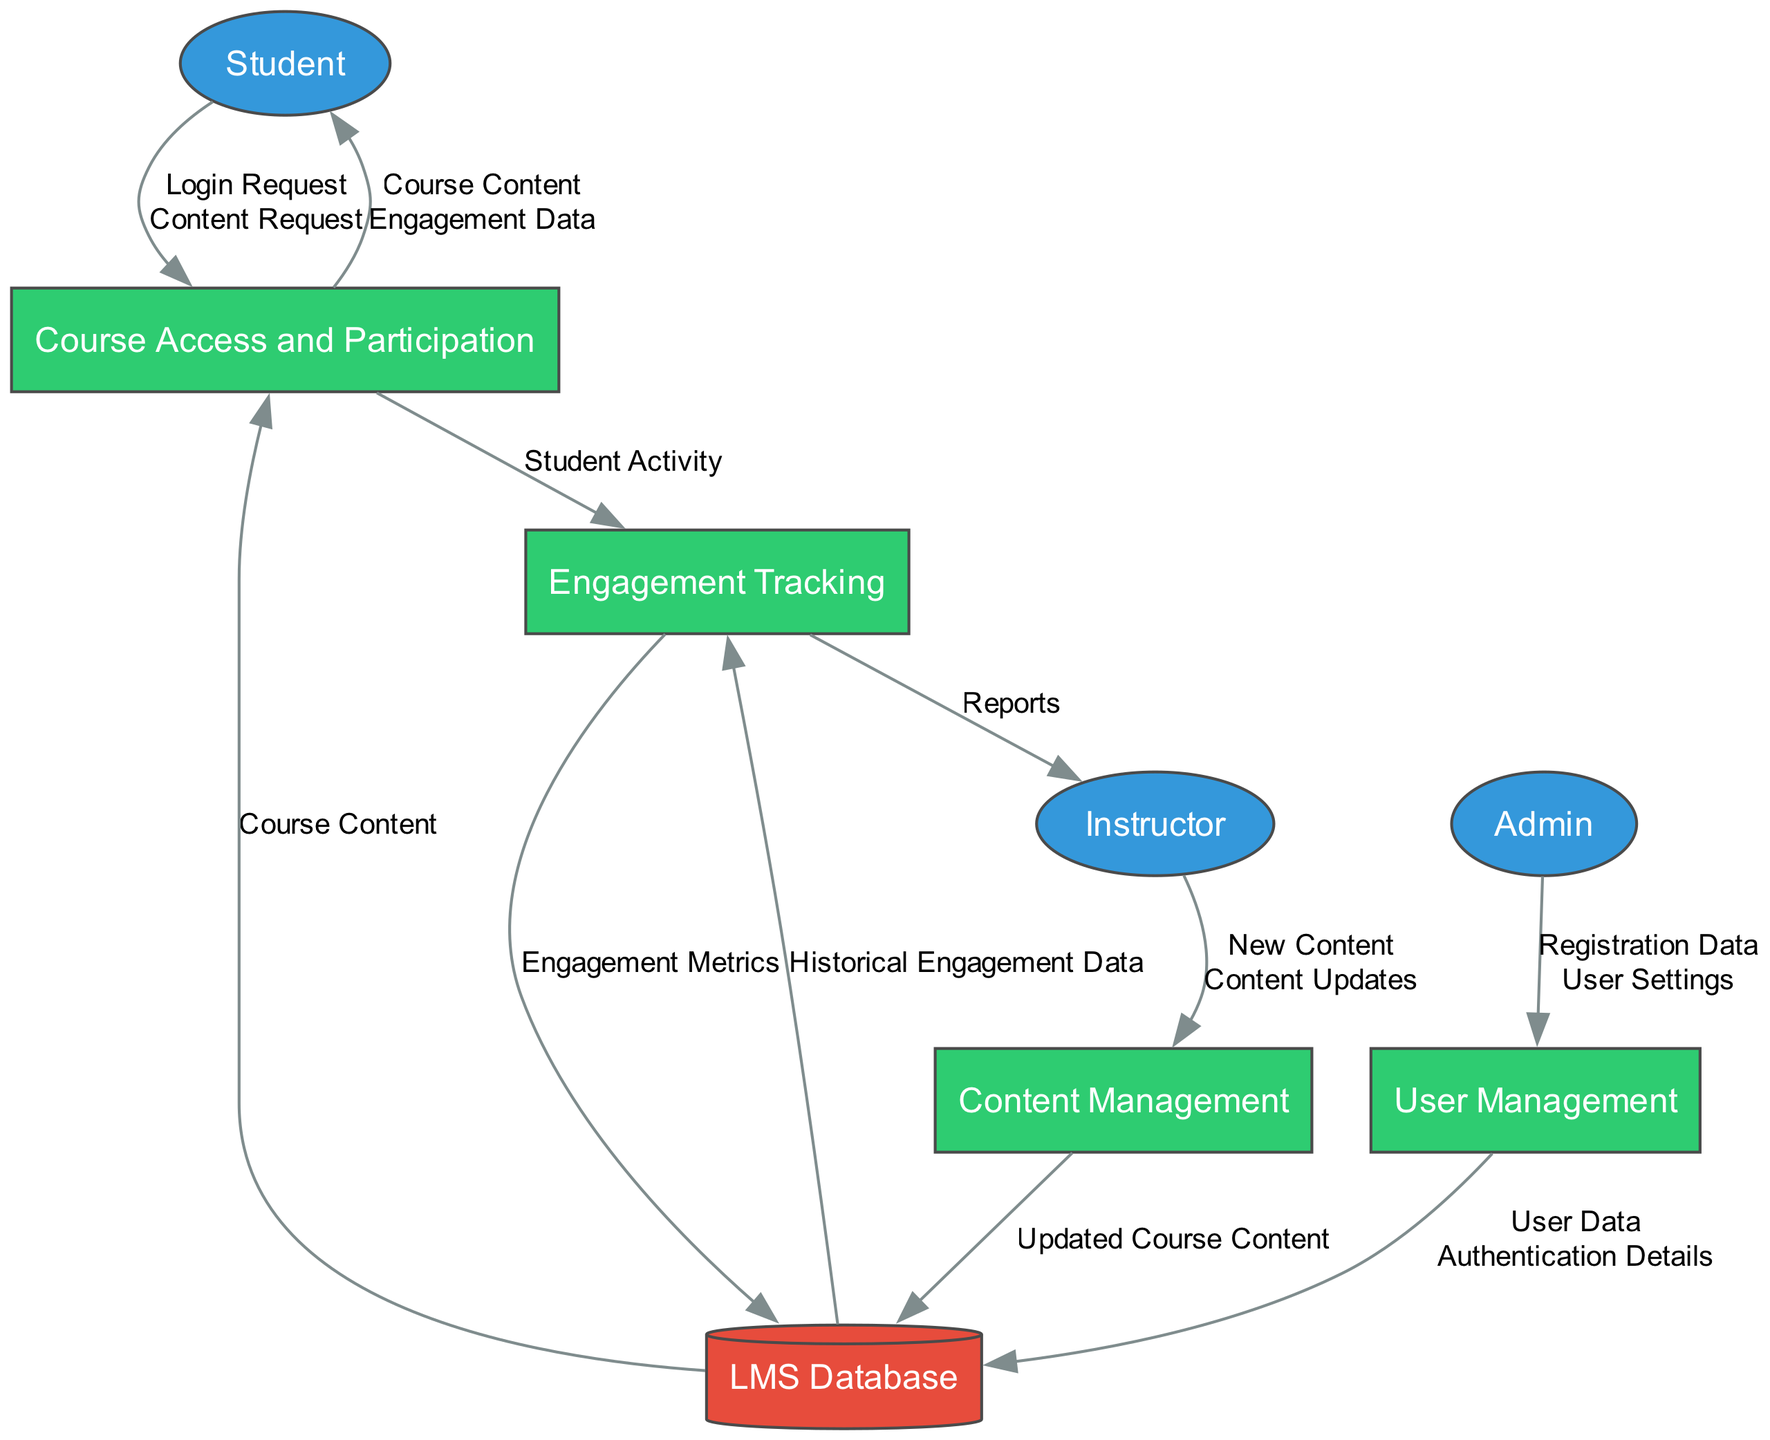What are the three external entities in the diagram? The diagram lists three external entities: Student, Instructor, and Admin.
Answer: Student, Instructor, Admin How many processes are in the diagram? There are four processes: Course Access and Participation, Content Management, User Management, and Engagement Tracking.
Answer: Four Which process handles student requests for content? The process named "Course Access and Participation" is responsible for handling student requests to view and participate in course content.
Answer: Course Access and Participation What data flows from the Engagement Tracking process to the Instructor? The Engagement Tracking process outputs "Reports" to the Instructor.
Answer: Reports What kind of data does the Course Access and Participation process receive from the Student? The Course Access and Participation process receives "Login Request" and "Content Request" data from the Student.
Answer: Login Request, Content Request Which external entity is responsible for managing user accounts? The Admin is the external entity responsible for managing user accounts in the system.
Answer: Admin What type of data flows into the LMS Database from the Content Management process? The Content Management process outputs "Updated Course Content" data into the LMS Database.
Answer: Updated Course Content Which data flow connects the LMS Database to the Engagement Tracking process? The LMS Database provides "Historical Engagement Data" to the Engagement Tracking process.
Answer: Historical Engagement Data What outputs does the User Management process generate? The User Management process outputs "User Data" and "Authentication Details."
Answer: User Data, Authentication Details Which process collects and analyzes data on user interactions? The process named "Engagement Tracking" is responsible for collecting and analyzing user interaction data.
Answer: Engagement Tracking 